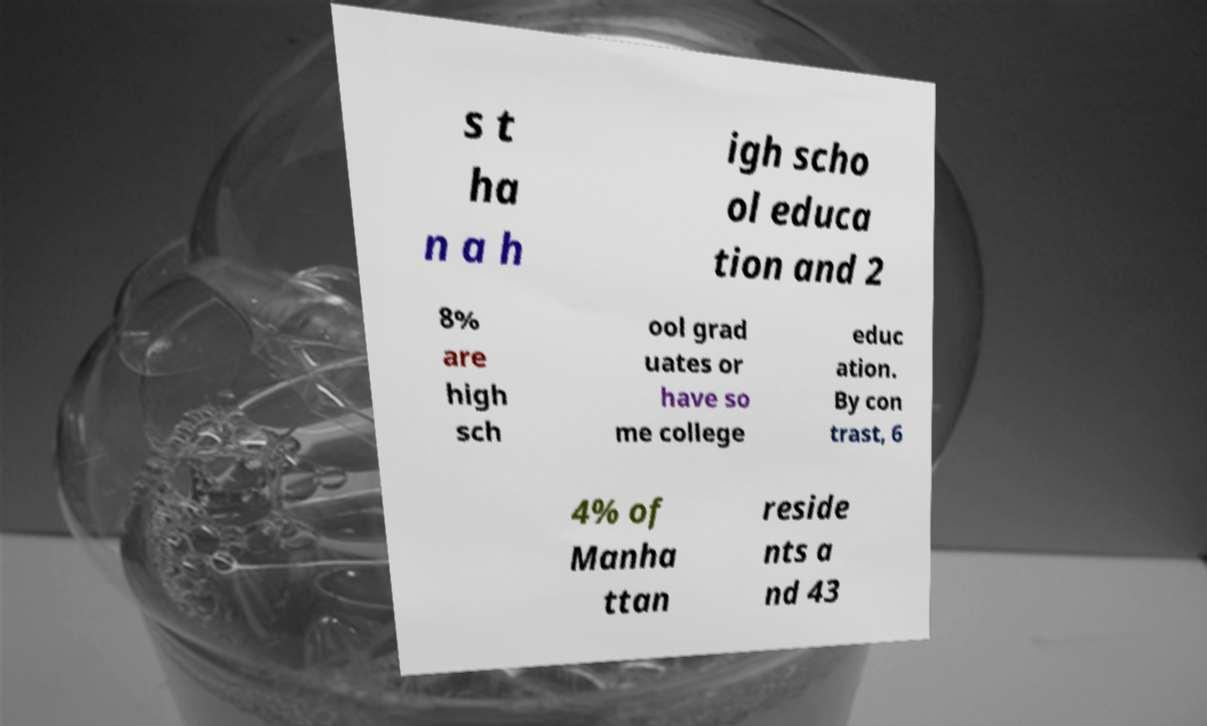For documentation purposes, I need the text within this image transcribed. Could you provide that? s t ha n a h igh scho ol educa tion and 2 8% are high sch ool grad uates or have so me college educ ation. By con trast, 6 4% of Manha ttan reside nts a nd 43 